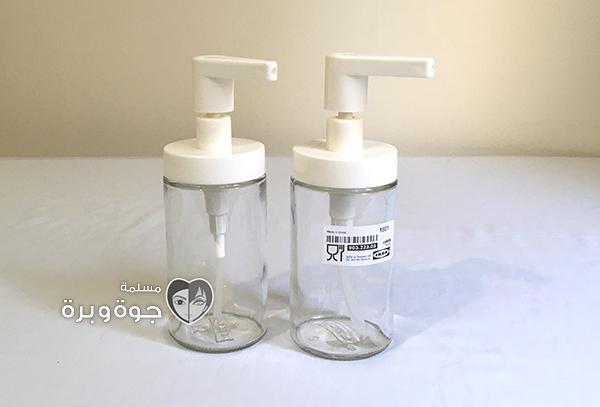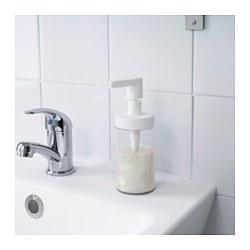The first image is the image on the left, the second image is the image on the right. Examine the images to the left and right. Is the description "Each image includes at least one clear glass cylinder with a white pump top, but the pump nozzles in the left and right images face opposite directions." accurate? Answer yes or no. Yes. The first image is the image on the left, the second image is the image on the right. Examine the images to the left and right. Is the description "There are exactly two dispensers." accurate? Answer yes or no. No. 